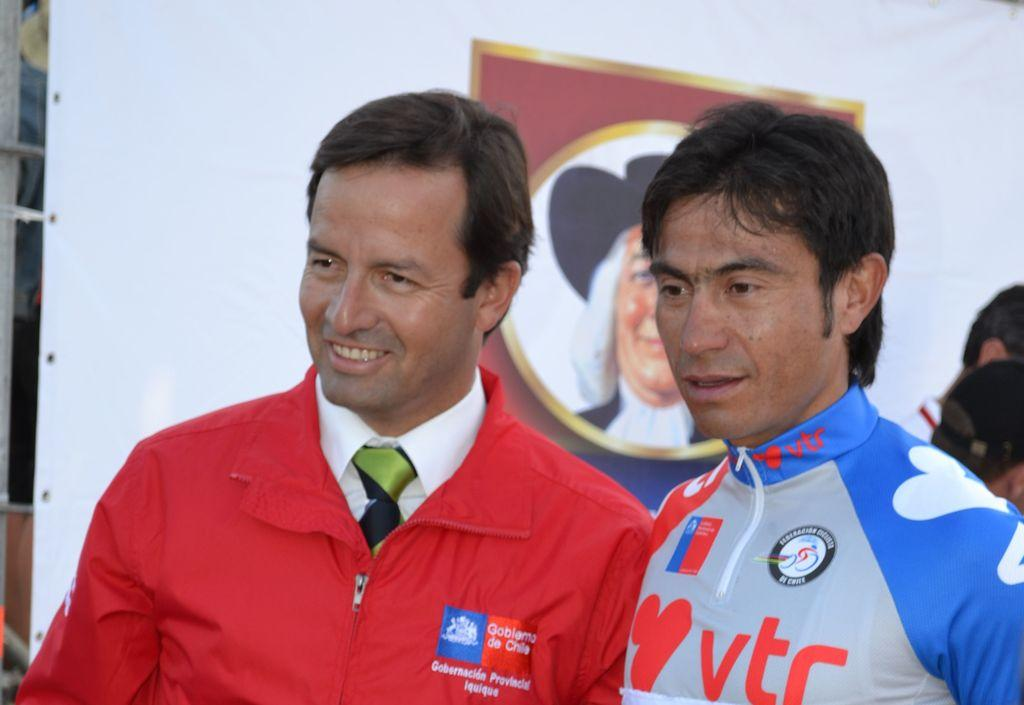Provide a one-sentence caption for the provided image. a man with a blue and gray shirt with TR on it. 